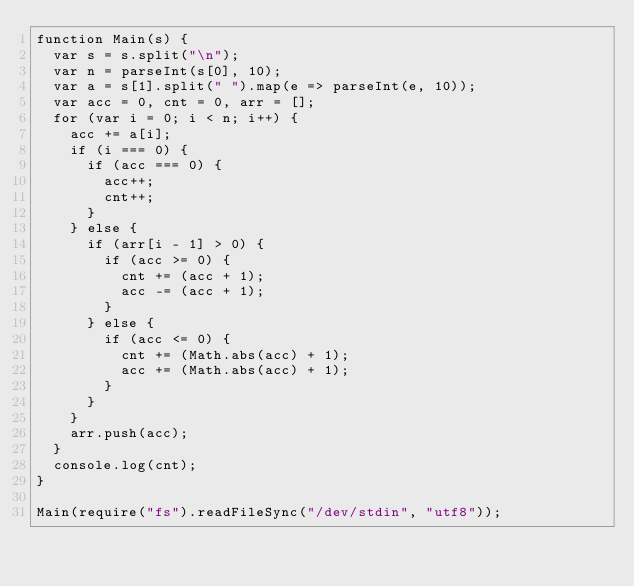<code> <loc_0><loc_0><loc_500><loc_500><_JavaScript_>function Main(s) {
  var s = s.split("\n");
  var n = parseInt(s[0], 10);
  var a = s[1].split(" ").map(e => parseInt(e, 10));
  var acc = 0, cnt = 0, arr = [];
  for (var i = 0; i < n; i++) {
    acc += a[i];
    if (i === 0) {
      if (acc === 0) {
        acc++;
        cnt++;
      }
    } else {
      if (arr[i - 1] > 0) {
        if (acc >= 0) {
          cnt += (acc + 1);
          acc -= (acc + 1);
        }
      } else {
        if (acc <= 0) {
          cnt += (Math.abs(acc) + 1);
          acc += (Math.abs(acc) + 1);
        }
      }
    }
    arr.push(acc);
  }
  console.log(cnt);
}

Main(require("fs").readFileSync("/dev/stdin", "utf8"));</code> 